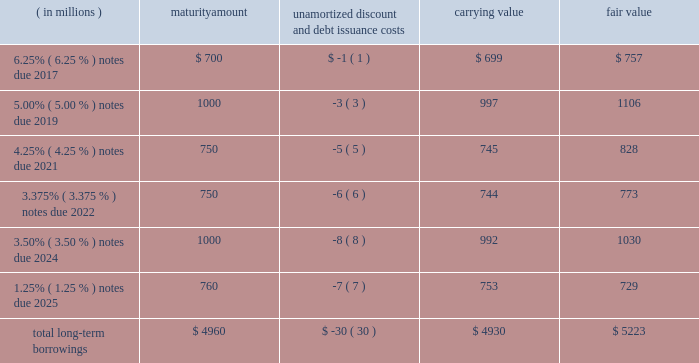12 .
Borrowings short-term borrowings 2015 revolving credit facility .
In march 2011 , the company entered into a five-year $ 3.5 billion unsecured revolving credit facility , which was amended in 2014 , 2013 and 2012 .
In april 2015 , the company 2019s credit facility was further amended to extend the maturity date to march 2020 and to increase the amount of the aggregate commitment to $ 4.0 billion ( the 201c2015 credit facility 201d ) .
The 2015 credit facility permits the company to request up to an additional $ 1.0 billion of borrowing capacity , subject to lender credit approval , increasing the overall size of the 2015 credit facility to an aggregate principal amount not to exceed $ 5.0 billion .
Interest on borrowings outstanding accrues at a rate based on the applicable london interbank offered rate plus a spread .
The 2015 credit facility requires the company not to exceed a maximum leverage ratio ( ratio of net debt to earnings before interest , taxes , depreciation and amortization , where net debt equals total debt less unrestricted cash ) of 3 to 1 , which was satisfied with a ratio of less than 1 to 1 at december 31 , 2015 .
The 2015 credit facility provides back-up liquidity to fund ongoing working capital for general corporate purposes and various investment opportunities .
At december 31 , 2015 , the company had no amount outstanding under the 2015 credit facility .
Commercial paper program .
On october 14 , 2009 , blackrock established a commercial paper program ( the 201ccp program 201d ) under which the company could issue unsecured commercial paper notes ( the 201ccp notes 201d ) on a private placement basis up to a maximum aggregate amount outstanding at any time of $ 4.0 billion as amended in april 2015 .
The cp program is currently supported by the 2015 credit facility .
At december 31 , 2015 , blackrock had no cp notes outstanding .
Long-term borrowings the carrying value and fair value of long-term borrowings estimated using market prices and foreign exchange rates at december 31 , 2015 included the following : ( in millions ) maturity amount unamortized discount and debt issuance costs carrying value fair value .
Long-term borrowings at december 31 , 2014 had a carrying value of $ 4.922 billion and a fair value of $ 5.309 billion determined using market prices at the end of december 2025 notes .
In may 2015 , the company issued 20ac700 million of 1.25% ( 1.25 % ) senior unsecured notes maturing on may 6 , 2025 ( the 201c2025 notes 201d ) .
The notes are listed on the new york stock exchange .
The net proceeds of the 2025 notes were used for general corporate purposes , including refinancing of outstanding indebtedness .
Interest of approximately $ 10 million per year based on current exchange rates is payable annually on may 6 of each year .
The 2025 notes may be redeemed in whole or in part prior to maturity at any time at the option of the company at a 201cmake-whole 201d redemption price .
The unamortized discount and debt issuance costs are being amortized over the remaining term of the 2025 notes .
Upon conversion to u.s .
Dollars the company designated the 20ac700 million debt offering as a net investment hedge to offset its currency exposure relating to its net investment in certain euro functional currency operations .
A gain of $ 19 million , net of tax , was recognized in other comprehensive income for 2015 .
No hedge ineffectiveness was recognized during 2015 .
2024 notes .
In march 2014 , the company issued $ 1.0 billion in aggregate principal amount of 3.50% ( 3.50 % ) senior unsecured and unsubordinated notes maturing on march 18 , 2024 ( the 201c2024 notes 201d ) .
The net proceeds of the 2024 notes were used to refinance certain indebtedness which matured in the fourth quarter of 2014 .
Interest is payable semi-annually in arrears on march 18 and september 18 of each year , or approximately $ 35 million per year .
The 2024 notes may be redeemed prior to maturity at any time in whole or in part at the option of the company at a 201cmake-whole 201d redemption price .
The unamortized discount and debt issuance costs are being amortized over the remaining term of the 2024 notes .
2022 notes .
In may 2012 , the company issued $ 1.5 billion in aggregate principal amount of unsecured unsubordinated obligations .
These notes were issued as two separate series of senior debt securities , including $ 750 million of 1.375% ( 1.375 % ) notes , which were repaid in june 2015 at maturity , and $ 750 million of 3.375% ( 3.375 % ) notes maturing in june 2022 ( the 201c2022 notes 201d ) .
Net proceeds were used to fund the repurchase of blackrock 2019s common stock and series b preferred from barclays and affiliates and for general corporate purposes .
Interest on the 2022 notes of approximately $ 25 million per year , respectively , is payable semi-annually on june 1 and december 1 of each year , which commenced december 1 , 2012 .
The 2022 notes may be redeemed prior to maturity at any time in whole or in part at the option of the company at a 201cmake-whole 201d redemption price .
The 201cmake-whole 201d redemption price represents a price , subject to the specific terms of the 2022 notes and related indenture , that is the greater of ( a ) par value and ( b ) the present value of future payments that will not be paid because of an early redemption , which is discounted at a fixed spread over a .
What portion of total long-term borrowings is due in the next 24 months as of december 31 , 2015? 
Computations: (700 / 4960)
Answer: 0.14113. 